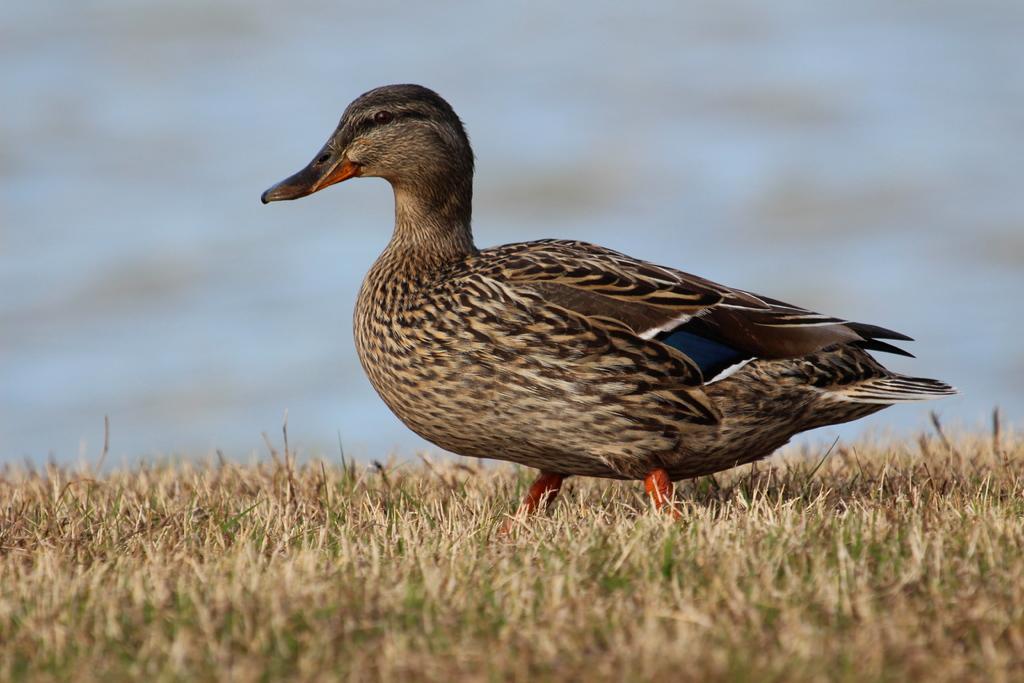In one or two sentences, can you explain what this image depicts? In the foreground of this image, there is a duck on the grass and the background image is blur. 